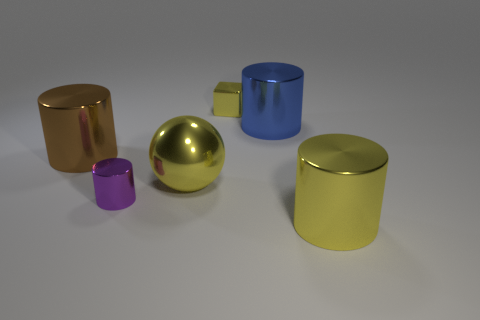Add 1 tiny things. How many objects exist? 7 Subtract all cylinders. How many objects are left? 2 Add 1 metal cubes. How many metal cubes are left? 2 Add 3 small gray metallic cubes. How many small gray metallic cubes exist? 3 Subtract 0 cyan balls. How many objects are left? 6 Subtract all purple shiny things. Subtract all small metallic cubes. How many objects are left? 4 